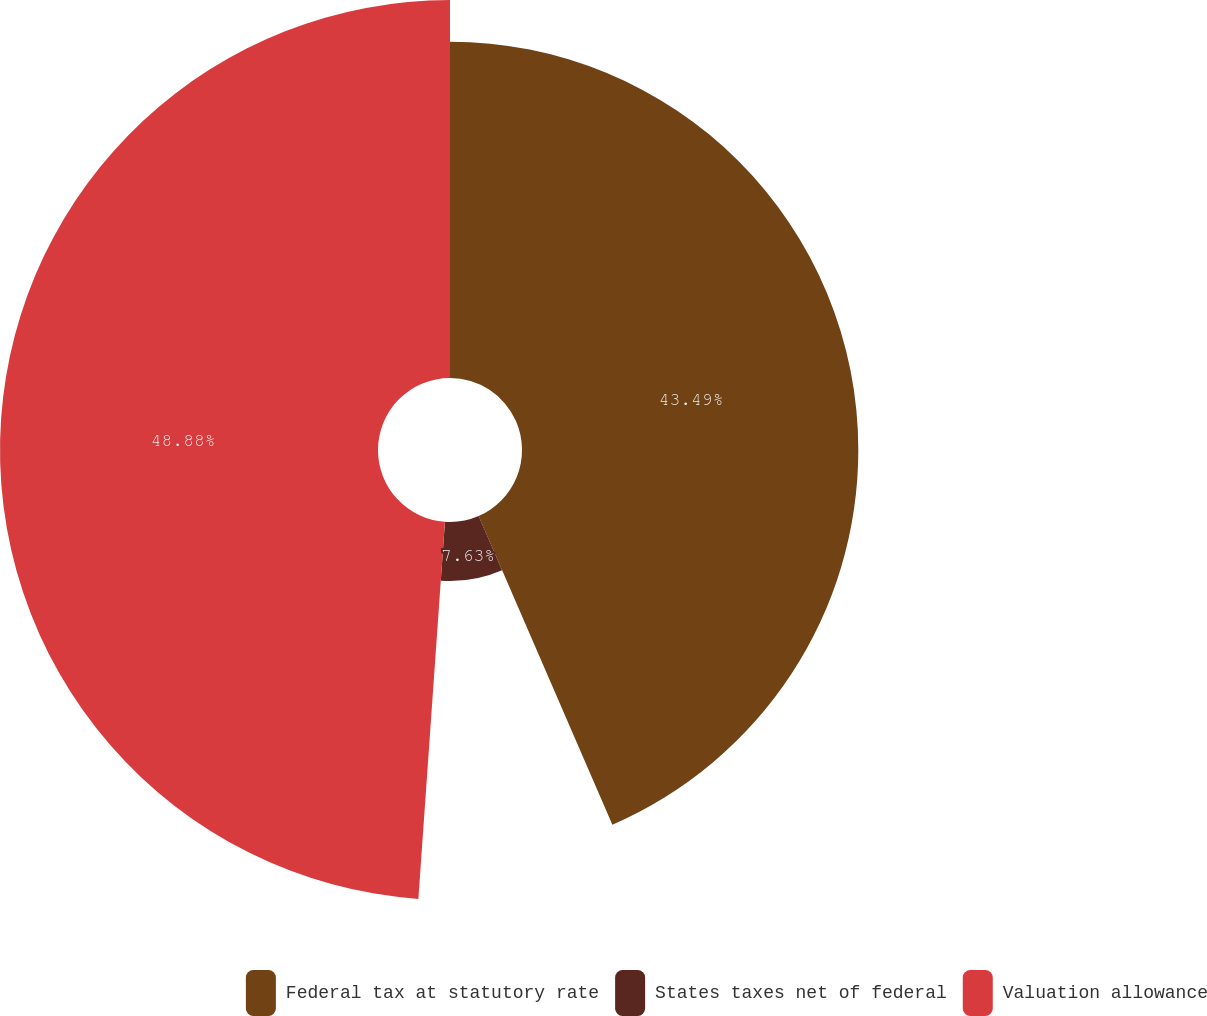Convert chart. <chart><loc_0><loc_0><loc_500><loc_500><pie_chart><fcel>Federal tax at statutory rate<fcel>States taxes net of federal<fcel>Valuation allowance<nl><fcel>43.49%<fcel>7.63%<fcel>48.88%<nl></chart> 